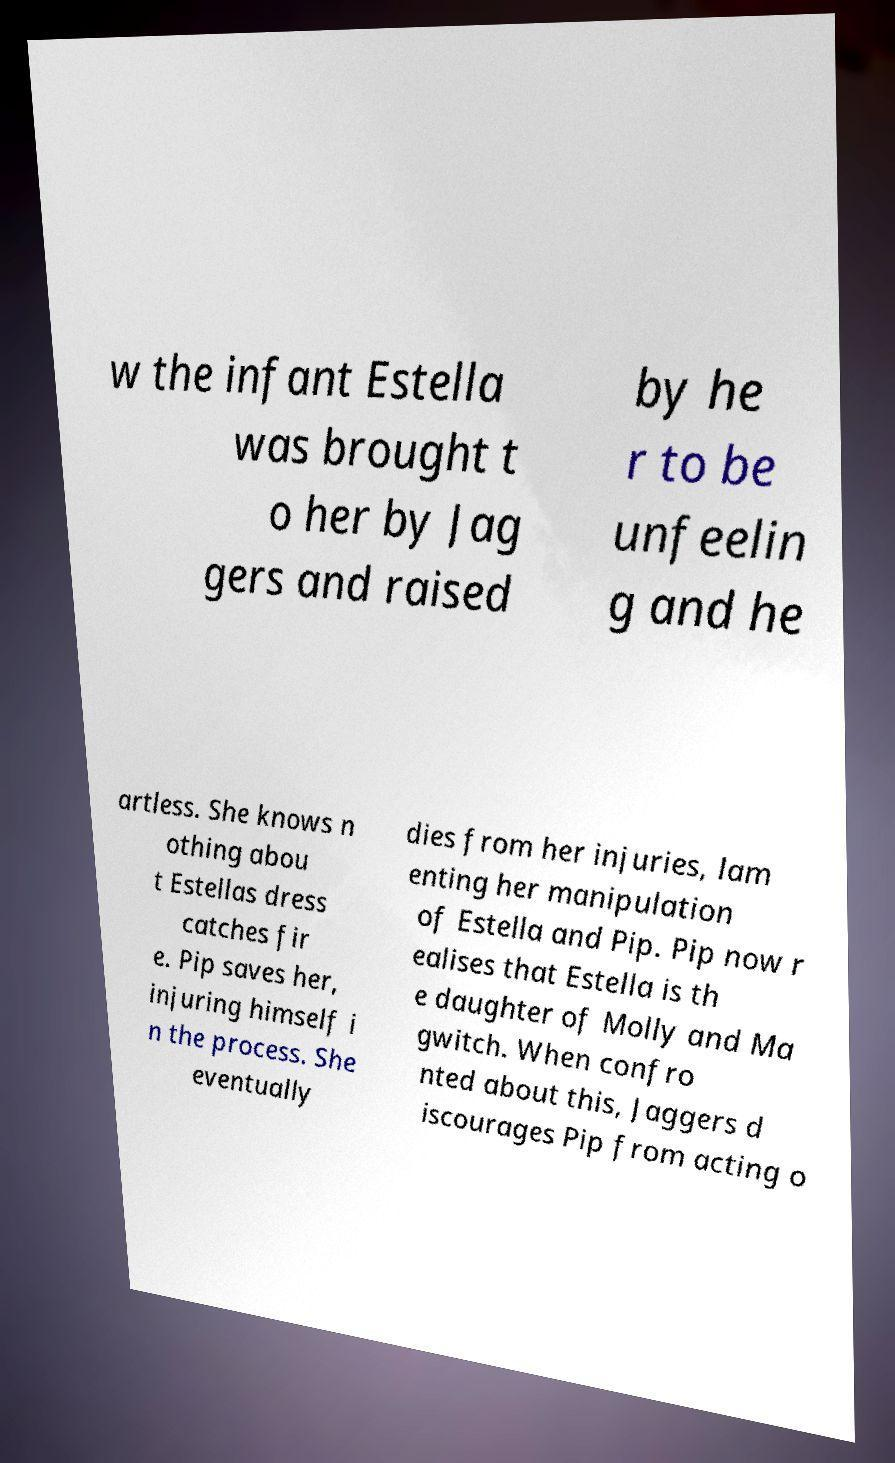I need the written content from this picture converted into text. Can you do that? w the infant Estella was brought t o her by Jag gers and raised by he r to be unfeelin g and he artless. She knows n othing abou t Estellas dress catches fir e. Pip saves her, injuring himself i n the process. She eventually dies from her injuries, lam enting her manipulation of Estella and Pip. Pip now r ealises that Estella is th e daughter of Molly and Ma gwitch. When confro nted about this, Jaggers d iscourages Pip from acting o 